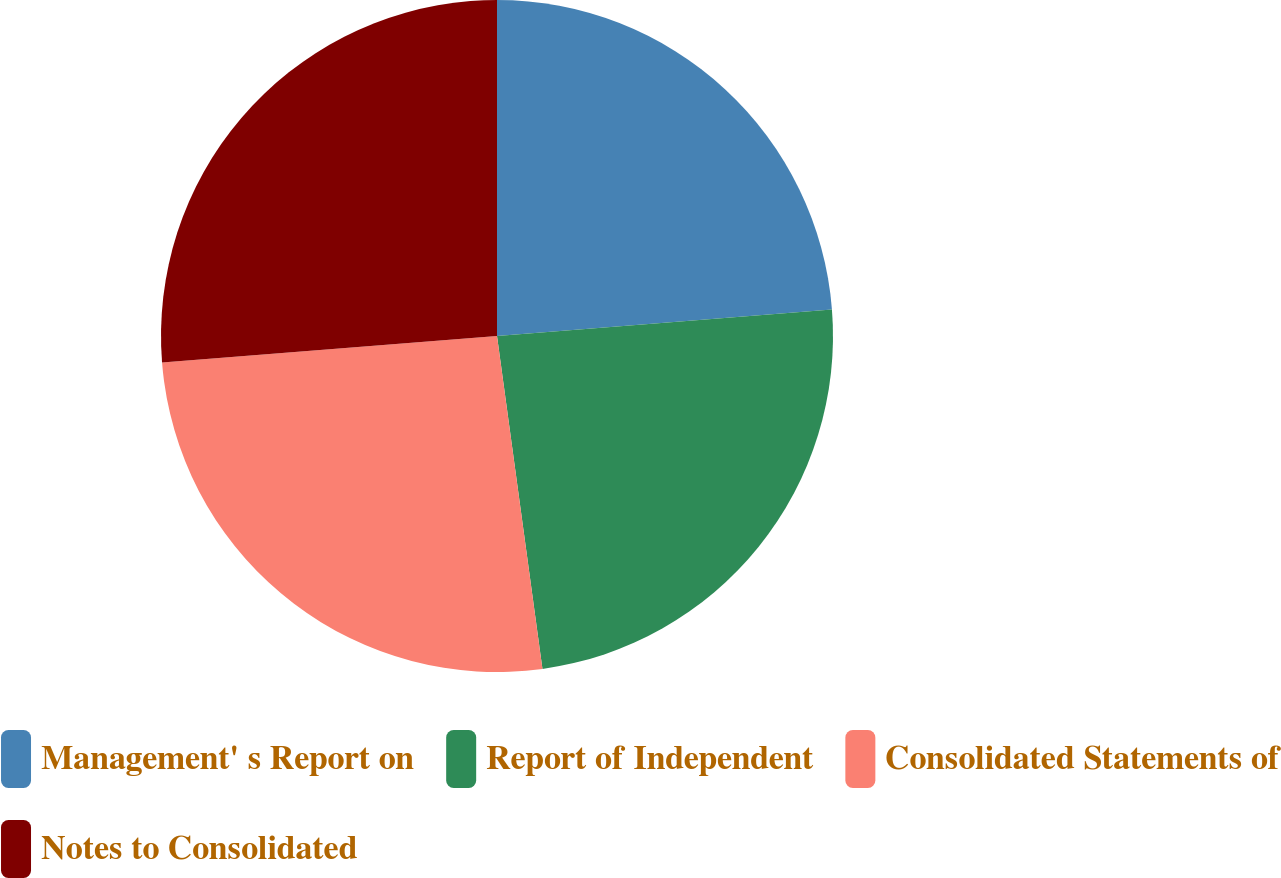Convert chart. <chart><loc_0><loc_0><loc_500><loc_500><pie_chart><fcel>Management' s Report on<fcel>Report of Independent<fcel>Consolidated Statements of<fcel>Notes to Consolidated<nl><fcel>23.74%<fcel>24.1%<fcel>25.9%<fcel>26.26%<nl></chart> 